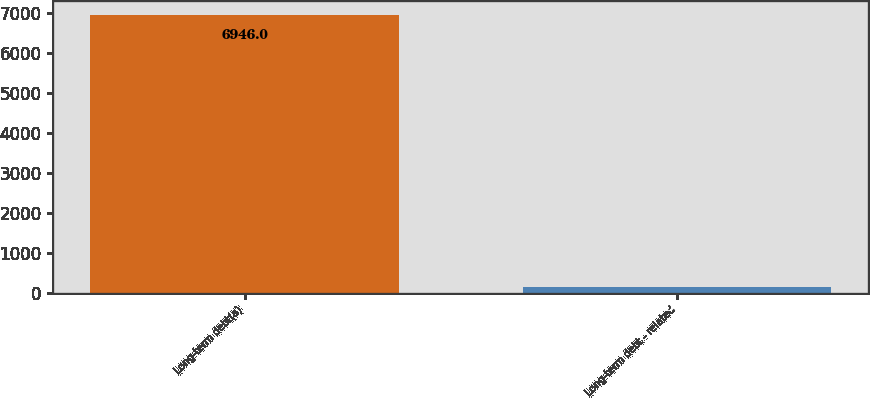Convert chart. <chart><loc_0><loc_0><loc_500><loc_500><bar_chart><fcel>Long-term debt(a)<fcel>Long-term debt - related<nl><fcel>6946<fcel>155<nl></chart> 